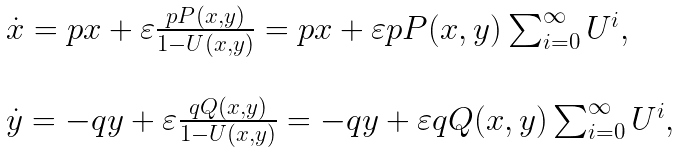<formula> <loc_0><loc_0><loc_500><loc_500>\begin{array} { l l } \dot { x } = p x + \varepsilon \frac { p P ( x , y ) } { 1 - U ( x , y ) } = p x + \varepsilon p P ( x , y ) \sum _ { i = 0 } ^ { \infty } U ^ { i } , \\ \\ \dot { y } = - q y + \varepsilon \frac { q Q ( x , y ) } { 1 - U ( x , y ) } = - q y + \varepsilon q Q ( x , y ) \sum _ { i = 0 } ^ { \infty } U ^ { i } , \end{array}</formula> 